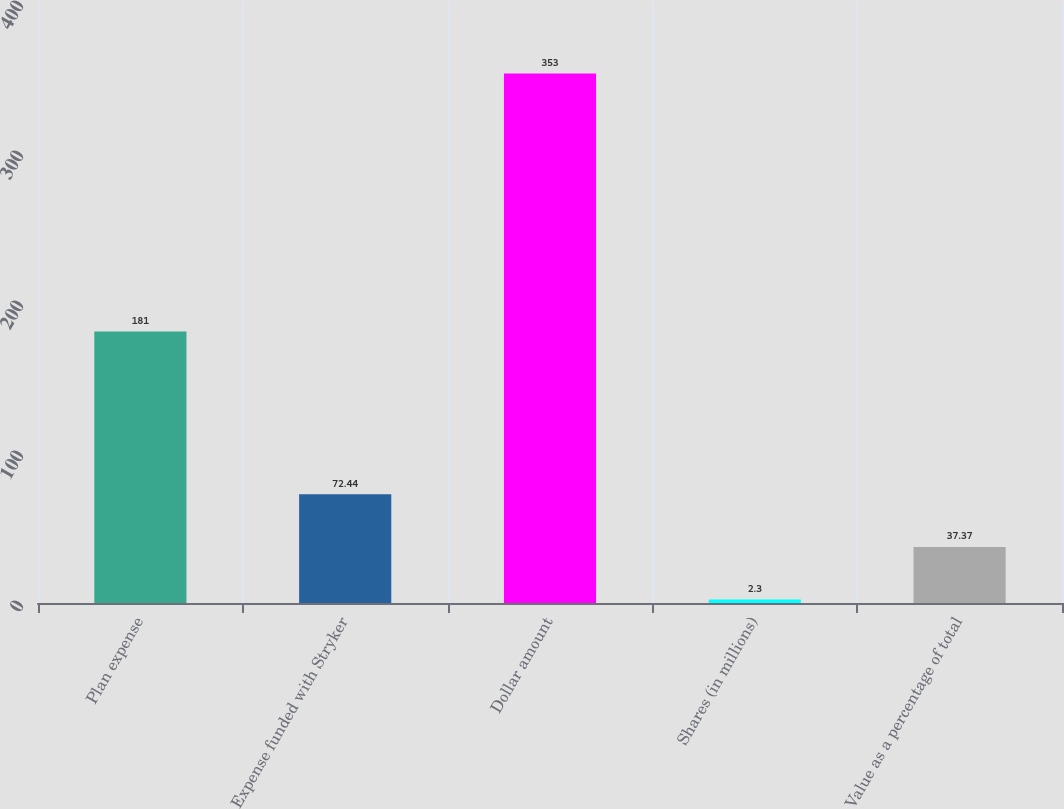Convert chart to OTSL. <chart><loc_0><loc_0><loc_500><loc_500><bar_chart><fcel>Plan expense<fcel>Expense funded with Stryker<fcel>Dollar amount<fcel>Shares (in millions)<fcel>Value as a percentage of total<nl><fcel>181<fcel>72.44<fcel>353<fcel>2.3<fcel>37.37<nl></chart> 